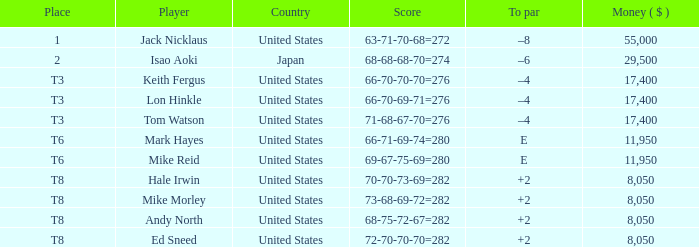In the united states, which golf course features a player by the name of hale irwin? 2.0. 